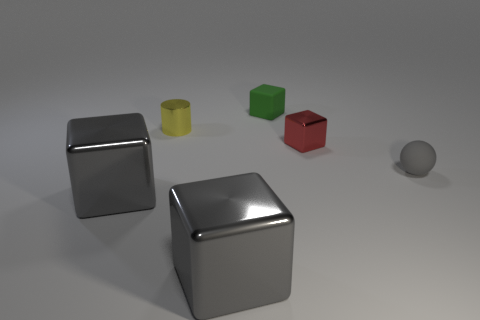How many other objects are there of the same size as the red thing?
Offer a very short reply. 3. There is a metal block that is both right of the yellow cylinder and on the left side of the red thing; what size is it?
Ensure brevity in your answer.  Large. What number of green things are the same shape as the red shiny thing?
Provide a succinct answer. 1. What is the material of the small ball?
Provide a succinct answer. Rubber. Is the shape of the small green thing the same as the small gray rubber object?
Offer a very short reply. No. Is there a green block that has the same material as the tiny red block?
Your response must be concise. No. There is a small object that is both in front of the yellow cylinder and left of the tiny matte sphere; what color is it?
Ensure brevity in your answer.  Red. There is a small block that is behind the cylinder; what is it made of?
Keep it short and to the point. Rubber. Is there a tiny yellow shiny object of the same shape as the small gray rubber object?
Make the answer very short. No. What number of other things are the same shape as the small red object?
Keep it short and to the point. 3. 